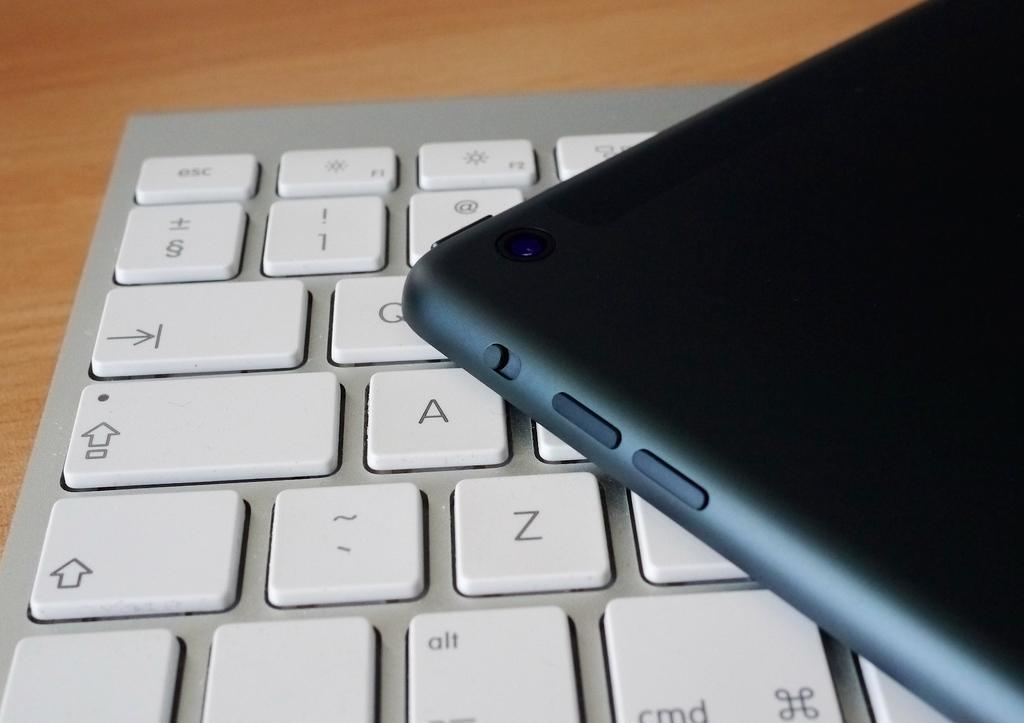Provide a one-sentence caption for the provided image. A cell phone sitting on a computer keyboard with keys A, Z, and Q visible. 